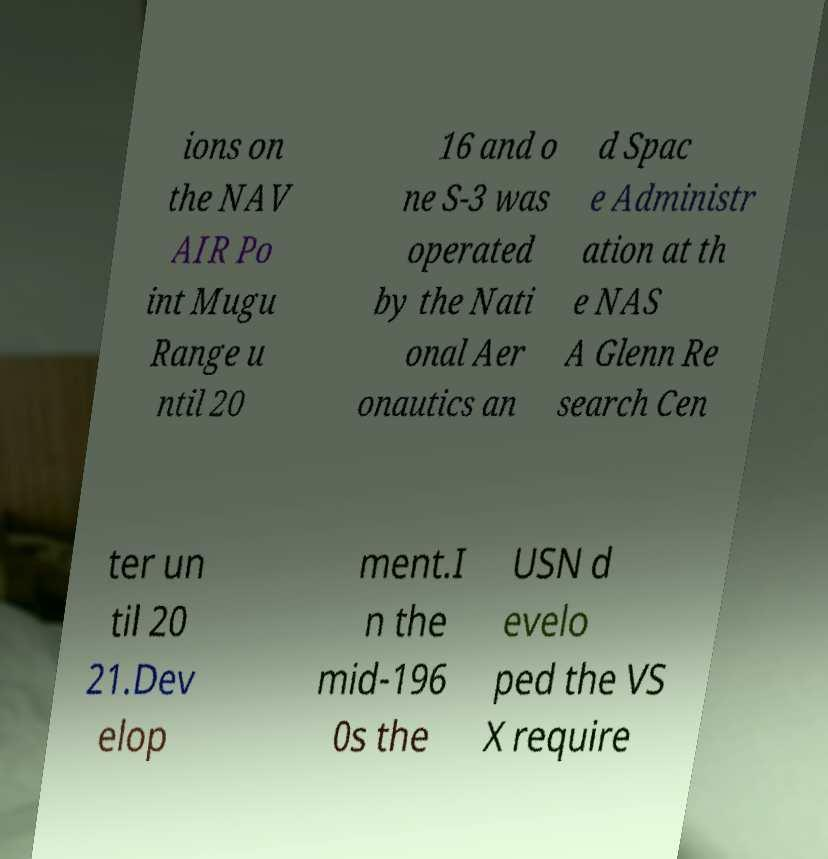Could you extract and type out the text from this image? ions on the NAV AIR Po int Mugu Range u ntil 20 16 and o ne S-3 was operated by the Nati onal Aer onautics an d Spac e Administr ation at th e NAS A Glenn Re search Cen ter un til 20 21.Dev elop ment.I n the mid-196 0s the USN d evelo ped the VS X require 